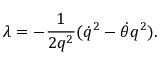<formula> <loc_0><loc_0><loc_500><loc_500>\lambda = - \frac { 1 } { 2 q ^ { 2 } } ( { \dot { q } } ^ { 2 } - \dot { \theta } q ^ { 2 } ) .</formula> 